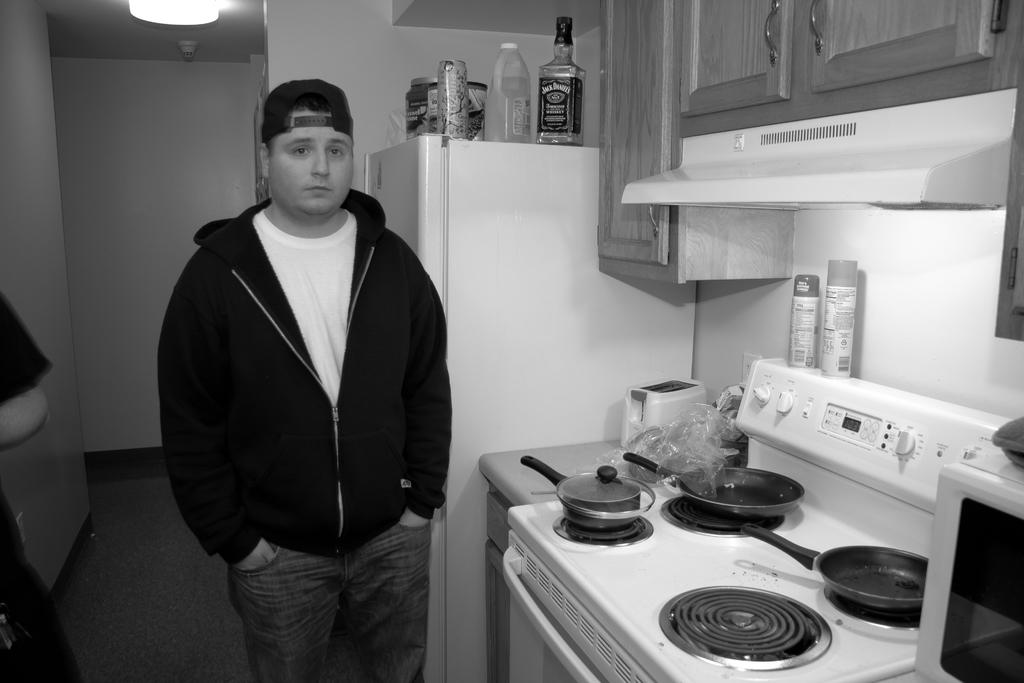<image>
Provide a brief description of the given image. A young man is standing in a kitchen with a bottle of Jack Daniels on top of the fridge. 